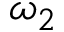<formula> <loc_0><loc_0><loc_500><loc_500>\omega _ { 2 }</formula> 